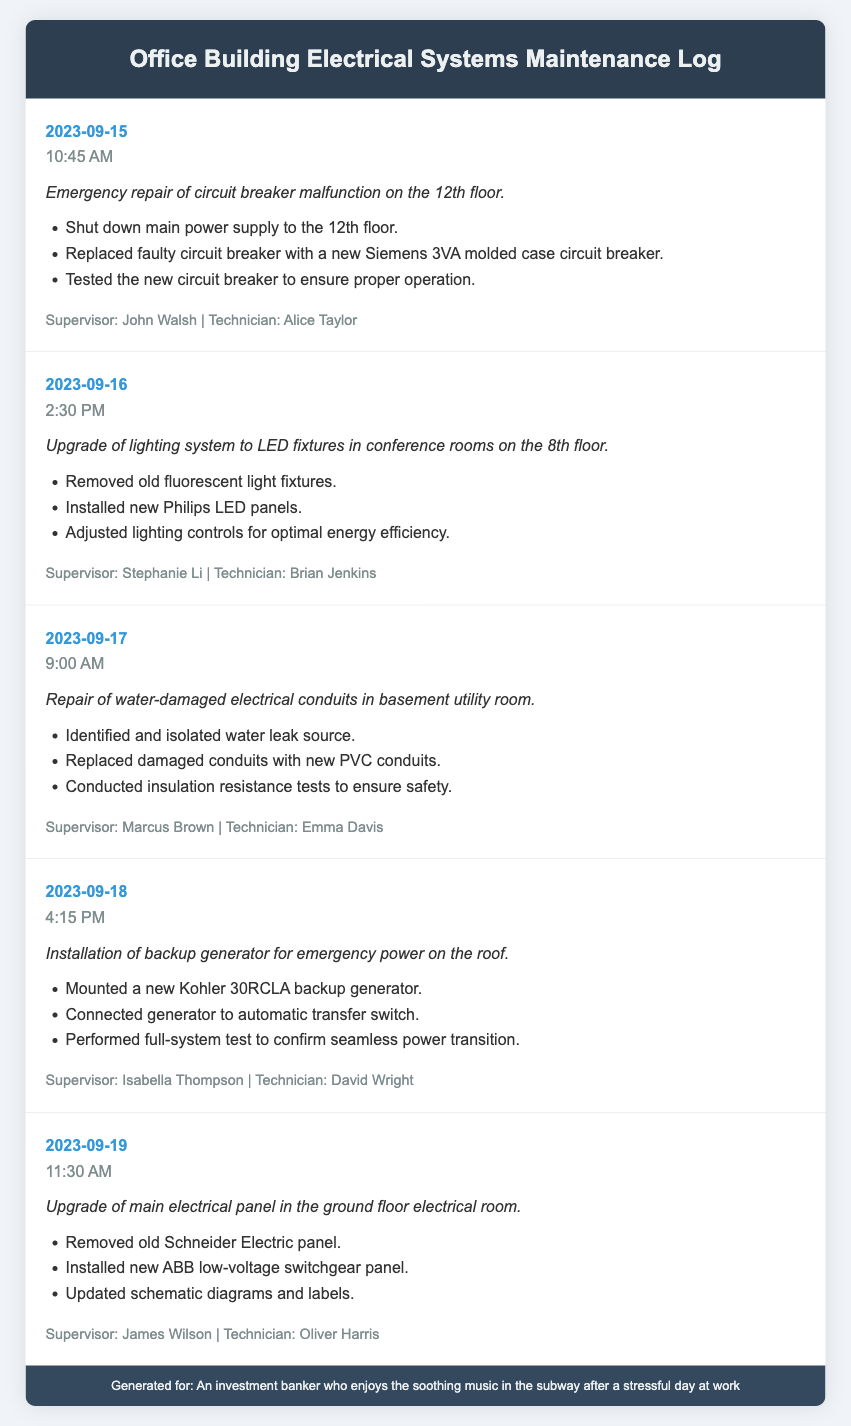What was repaired on September 15, 2023? The log entry on September 15, 2023, describes an emergency repair of a circuit breaker malfunction on the 12th floor.
Answer: Circuit breaker malfunction Who performed the lighting upgrade on September 16, 2023? The technician for the lighting upgrade on September 16, 2023, was Brian Jenkins.
Answer: Brian Jenkins What type of generator was installed on September 18, 2023? The log states that a Kohler 30RCLA backup generator was installed on September 18, 2023.
Answer: Kohler 30RCLA How many emergency repairs or upgrades occurred in total according to the document? There are five log entries detailing repairs and upgrades, indicating five events.
Answer: Five What actions were taken during the repair of water-damaged conduits? The actions included identifying the leak, replacing damaged conduits, and conducting insulation resistance tests.
Answer: Identified leak, replaced conduits, conducted tests Which floor had the lighting upgrade performed? The lighting upgrade on September 16, 2023, was performed in the conference rooms on the 8th floor.
Answer: 8th floor Who supervised the installation of the backup generator? The supervisor for the generator installation was Isabella Thompson.
Answer: Isabella Thompson What date was the main electrical panel upgraded? The upgrade of the main electrical panel occurred on September 19, 2023.
Answer: September 19, 2023 What brand of circuit breaker was used on September 15, 2023? The document states that a Siemens 3VA molded case circuit breaker was used for the emergency repair.
Answer: Siemens 3VA 